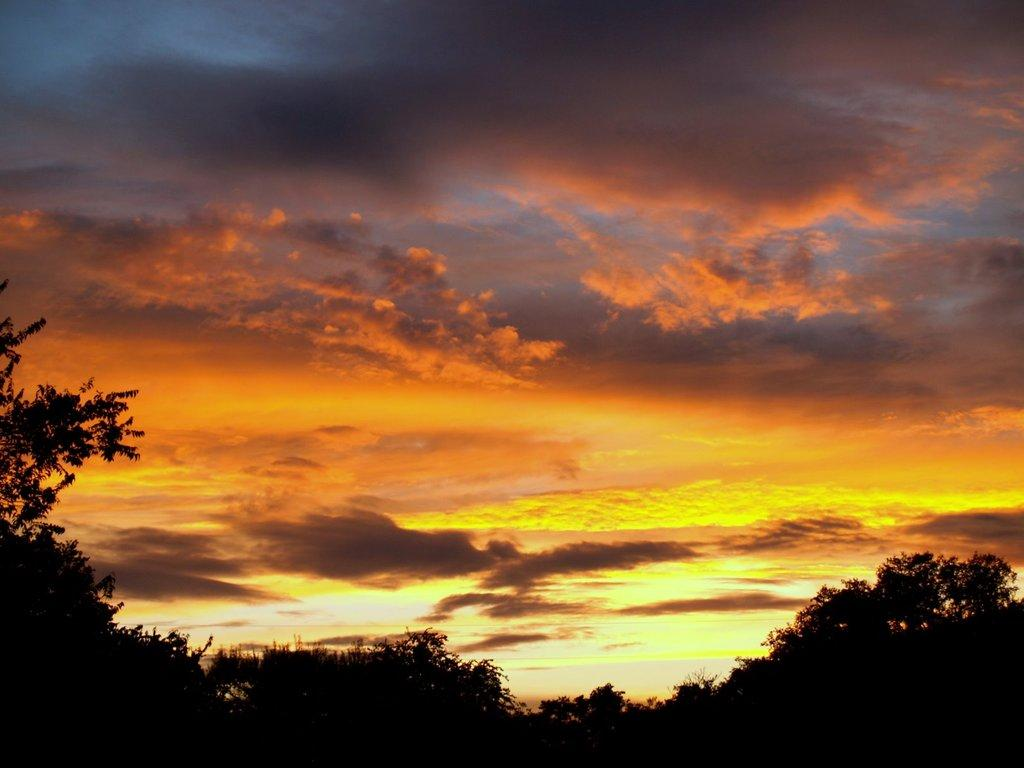What type of vegetation can be seen in the image? There are trees in the image. How would you describe the sky in the image? The sky is cloudy and has a pale orange color. What type of pie is being served in the image? There is no pie present in the image; it features trees and a cloudy, pale orange sky. What type of gold object is visible in the image? There is no gold object present in the image. 